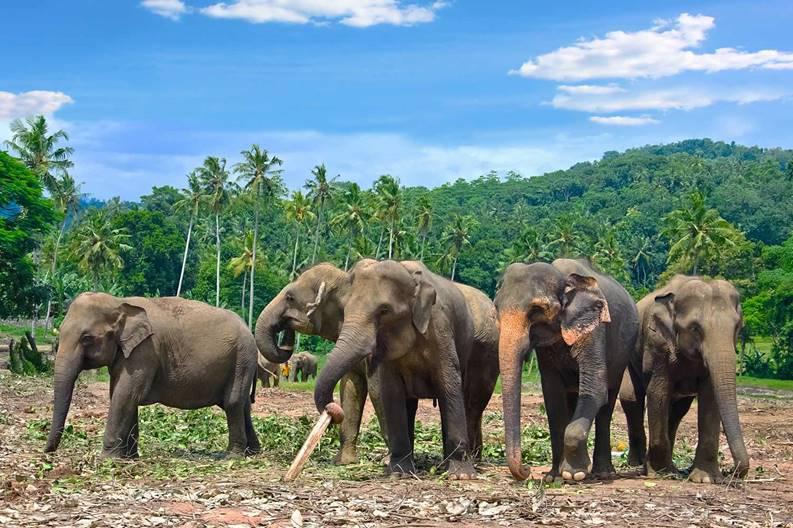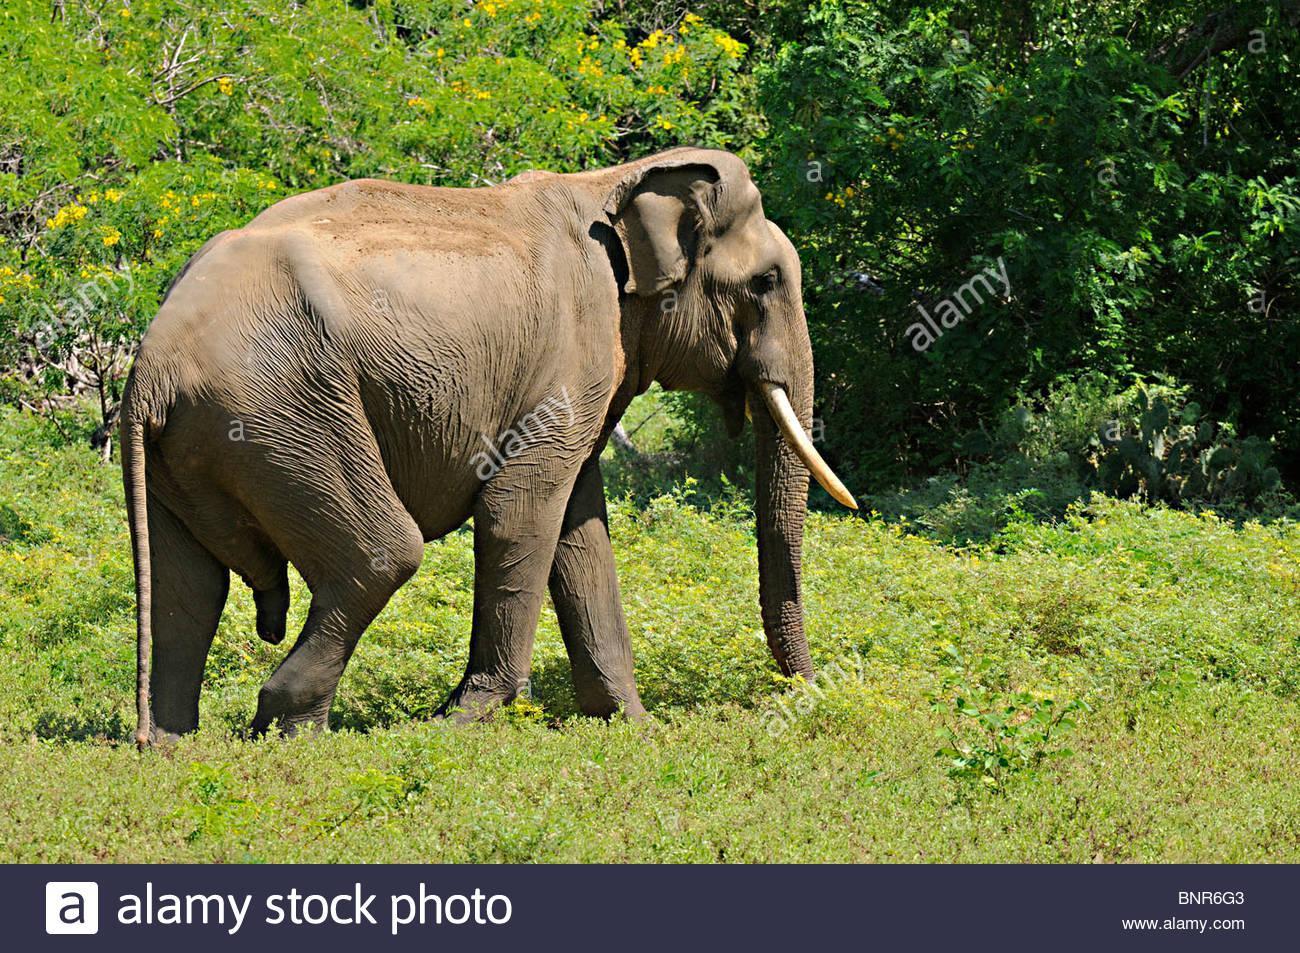The first image is the image on the left, the second image is the image on the right. Considering the images on both sides, is "At least one elephant is in the foreground of an image standing in water." valid? Answer yes or no. No. The first image is the image on the left, the second image is the image on the right. Assess this claim about the two images: "At least one elephant is standing in water.". Correct or not? Answer yes or no. No. 